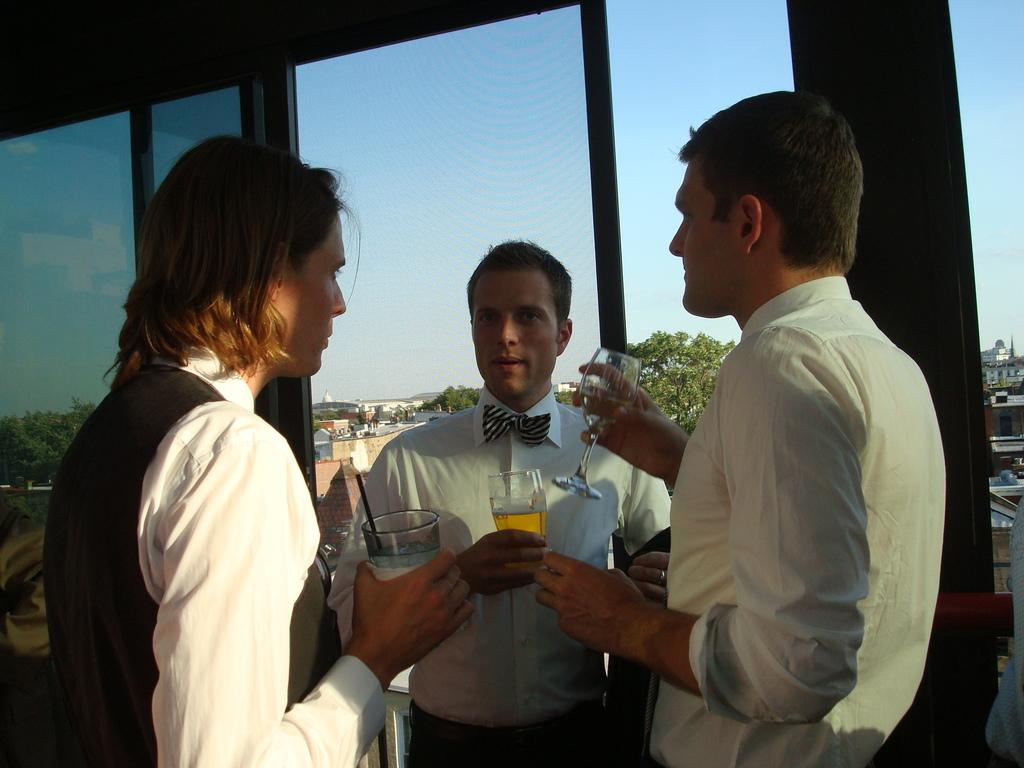How many men are in the image? There are three men in the image. What are the men doing in the image? The men are standing and holding glasses. What can be seen through the glass windows in the image? Buildings, trees, and the sky are visible through the glass windows. What is the creator of the glass windows doing in the image? There is no creator of the glass windows present in the image. Can you describe the nose of the man on the left in the image? The provided facts do not mention any details about the men's noses, so we cannot describe the nose of the man on the left. 